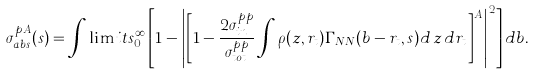Convert formula to latex. <formula><loc_0><loc_0><loc_500><loc_500>\sigma _ { a b s } ^ { p A } ( s ) = \int \lim i t s _ { 0 } ^ { \infty } \left [ 1 - { \left | \left [ 1 - \frac { 2 \sigma _ { i n } ^ { p p } } { \sigma _ { t o t } ^ { p p } } \int \rho ( z , { r } _ { t } ) \Gamma _ { N N } ( { b } - { r } _ { t } , s ) d \, z \, d { r } _ { t } \right ] ^ { A } \right | } ^ { 2 } \right ] d { b } .</formula> 